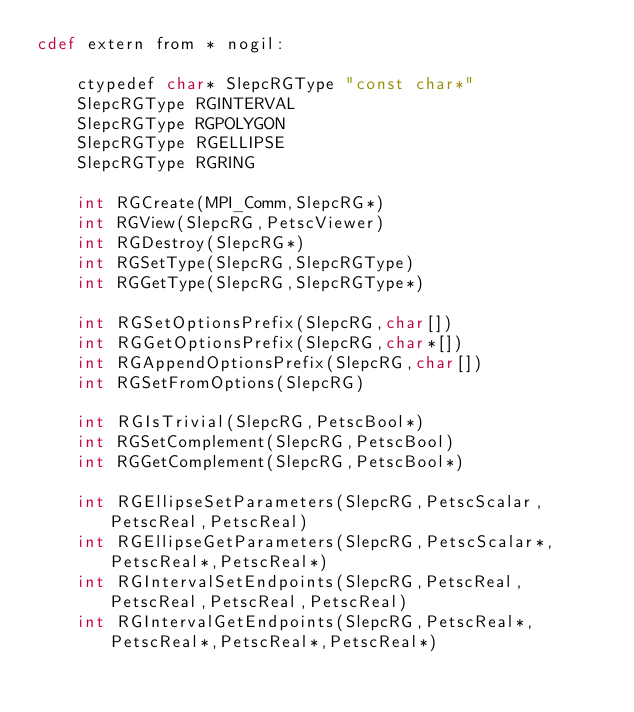<code> <loc_0><loc_0><loc_500><loc_500><_Cython_>cdef extern from * nogil:

    ctypedef char* SlepcRGType "const char*"
    SlepcRGType RGINTERVAL
    SlepcRGType RGPOLYGON
    SlepcRGType RGELLIPSE
    SlepcRGType RGRING

    int RGCreate(MPI_Comm,SlepcRG*)
    int RGView(SlepcRG,PetscViewer)
    int RGDestroy(SlepcRG*)
    int RGSetType(SlepcRG,SlepcRGType)
    int RGGetType(SlepcRG,SlepcRGType*)

    int RGSetOptionsPrefix(SlepcRG,char[])
    int RGGetOptionsPrefix(SlepcRG,char*[])
    int RGAppendOptionsPrefix(SlepcRG,char[])
    int RGSetFromOptions(SlepcRG)

    int RGIsTrivial(SlepcRG,PetscBool*)
    int RGSetComplement(SlepcRG,PetscBool)
    int RGGetComplement(SlepcRG,PetscBool*)

    int RGEllipseSetParameters(SlepcRG,PetscScalar,PetscReal,PetscReal)
    int RGEllipseGetParameters(SlepcRG,PetscScalar*,PetscReal*,PetscReal*)
    int RGIntervalSetEndpoints(SlepcRG,PetscReal,PetscReal,PetscReal,PetscReal)
    int RGIntervalGetEndpoints(SlepcRG,PetscReal*,PetscReal*,PetscReal*,PetscReal*)

</code> 